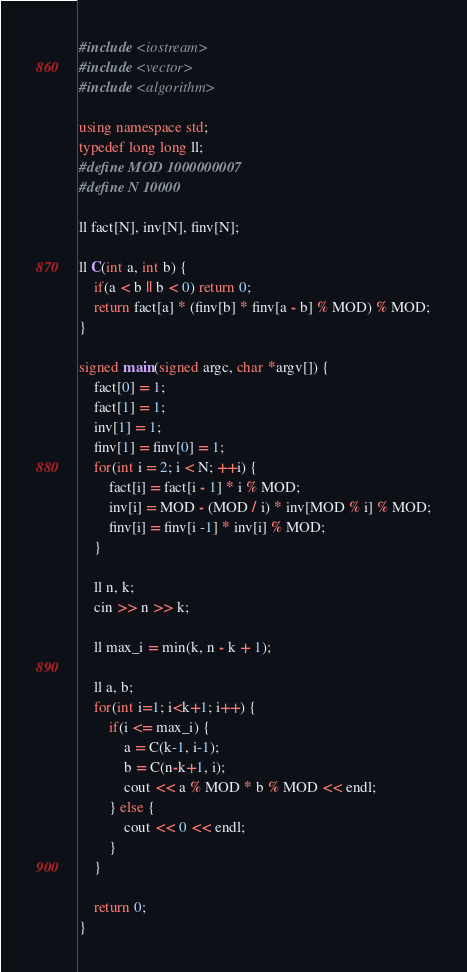<code> <loc_0><loc_0><loc_500><loc_500><_C++_>#include <iostream>
#include <vector>
#include <algorithm>

using namespace std;
typedef long long ll;
#define MOD 1000000007
#define N 10000

ll fact[N], inv[N], finv[N];

ll C(int a, int b) {
    if(a < b || b < 0) return 0;
    return fact[a] * (finv[b] * finv[a - b] % MOD) % MOD;
}

signed main(signed argc, char *argv[]) {
    fact[0] = 1;
    fact[1] = 1;
    inv[1] = 1;
    finv[1] = finv[0] = 1;
    for(int i = 2; i < N; ++i) {
        fact[i] = fact[i - 1] * i % MOD;
        inv[i] = MOD - (MOD / i) * inv[MOD % i] % MOD;
        finv[i] = finv[i -1] * inv[i] % MOD;
    }

    ll n, k;
    cin >> n >> k;

    ll max_i = min(k, n - k + 1);

    ll a, b;
    for(int i=1; i<k+1; i++) {
        if(i <= max_i) {
            a = C(k-1, i-1);
            b = C(n-k+1, i);
            cout << a % MOD * b % MOD << endl;
        } else {
            cout << 0 << endl;
        }
    }

    return 0;
}</code> 